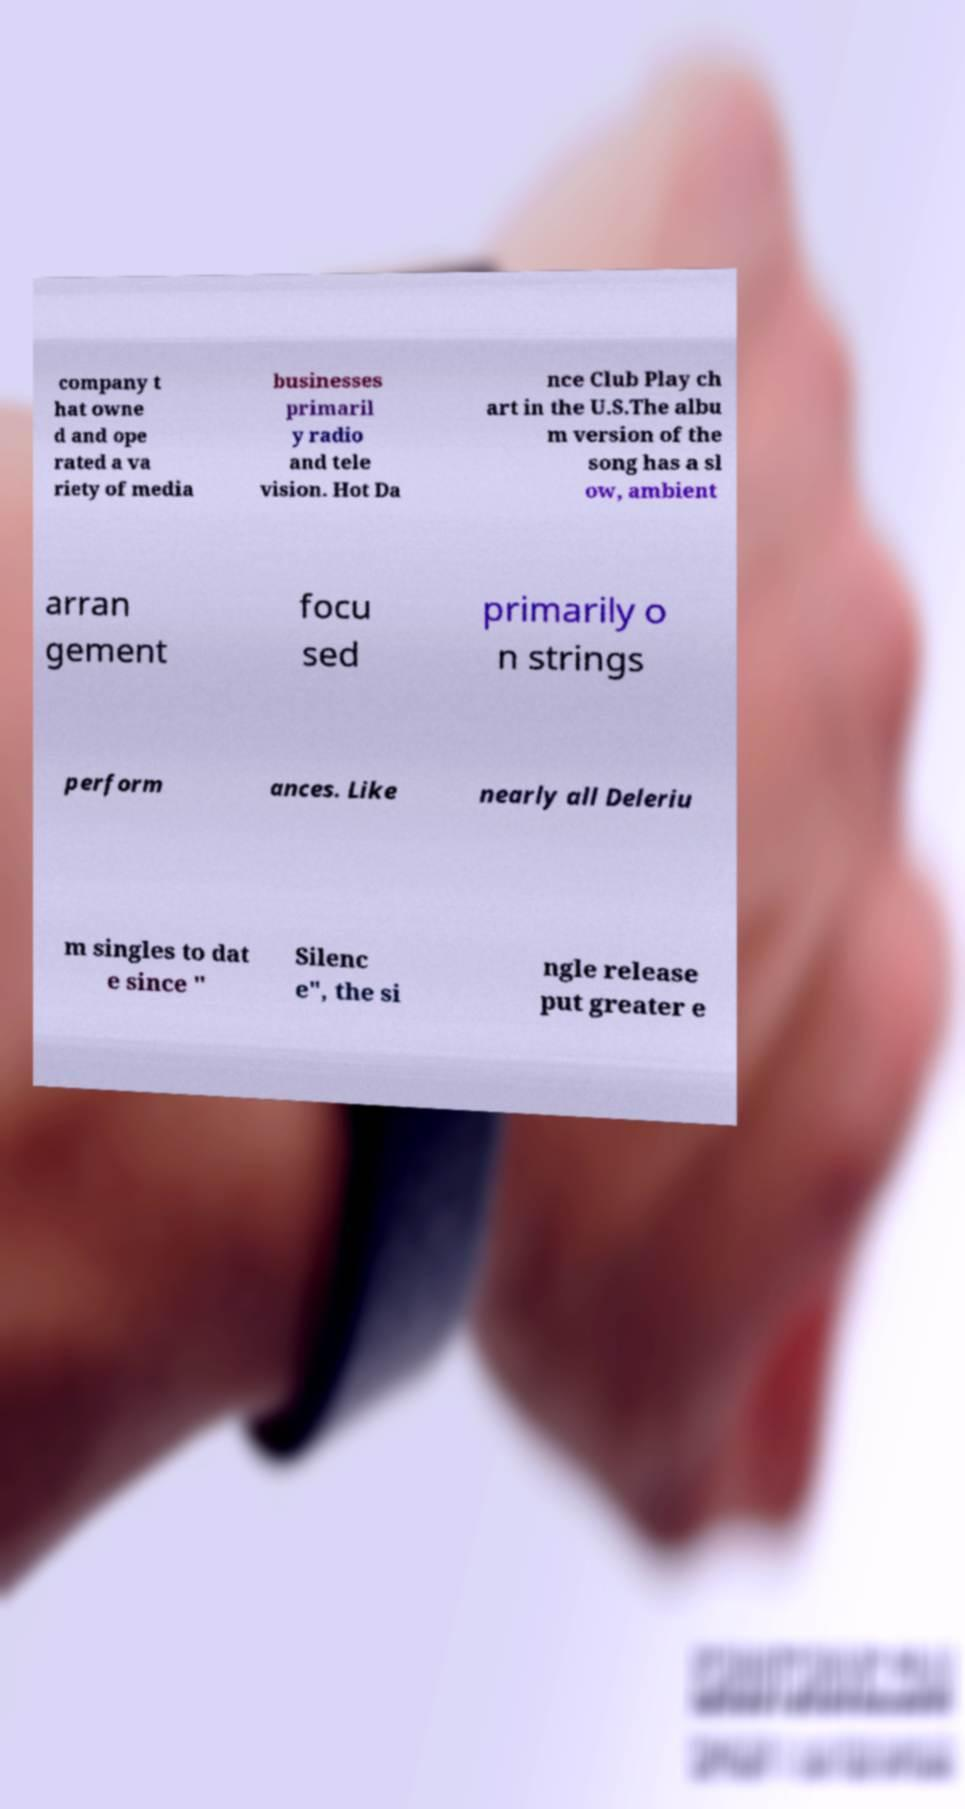What messages or text are displayed in this image? I need them in a readable, typed format. company t hat owne d and ope rated a va riety of media businesses primaril y radio and tele vision. Hot Da nce Club Play ch art in the U.S.The albu m version of the song has a sl ow, ambient arran gement focu sed primarily o n strings perform ances. Like nearly all Deleriu m singles to dat e since " Silenc e", the si ngle release put greater e 